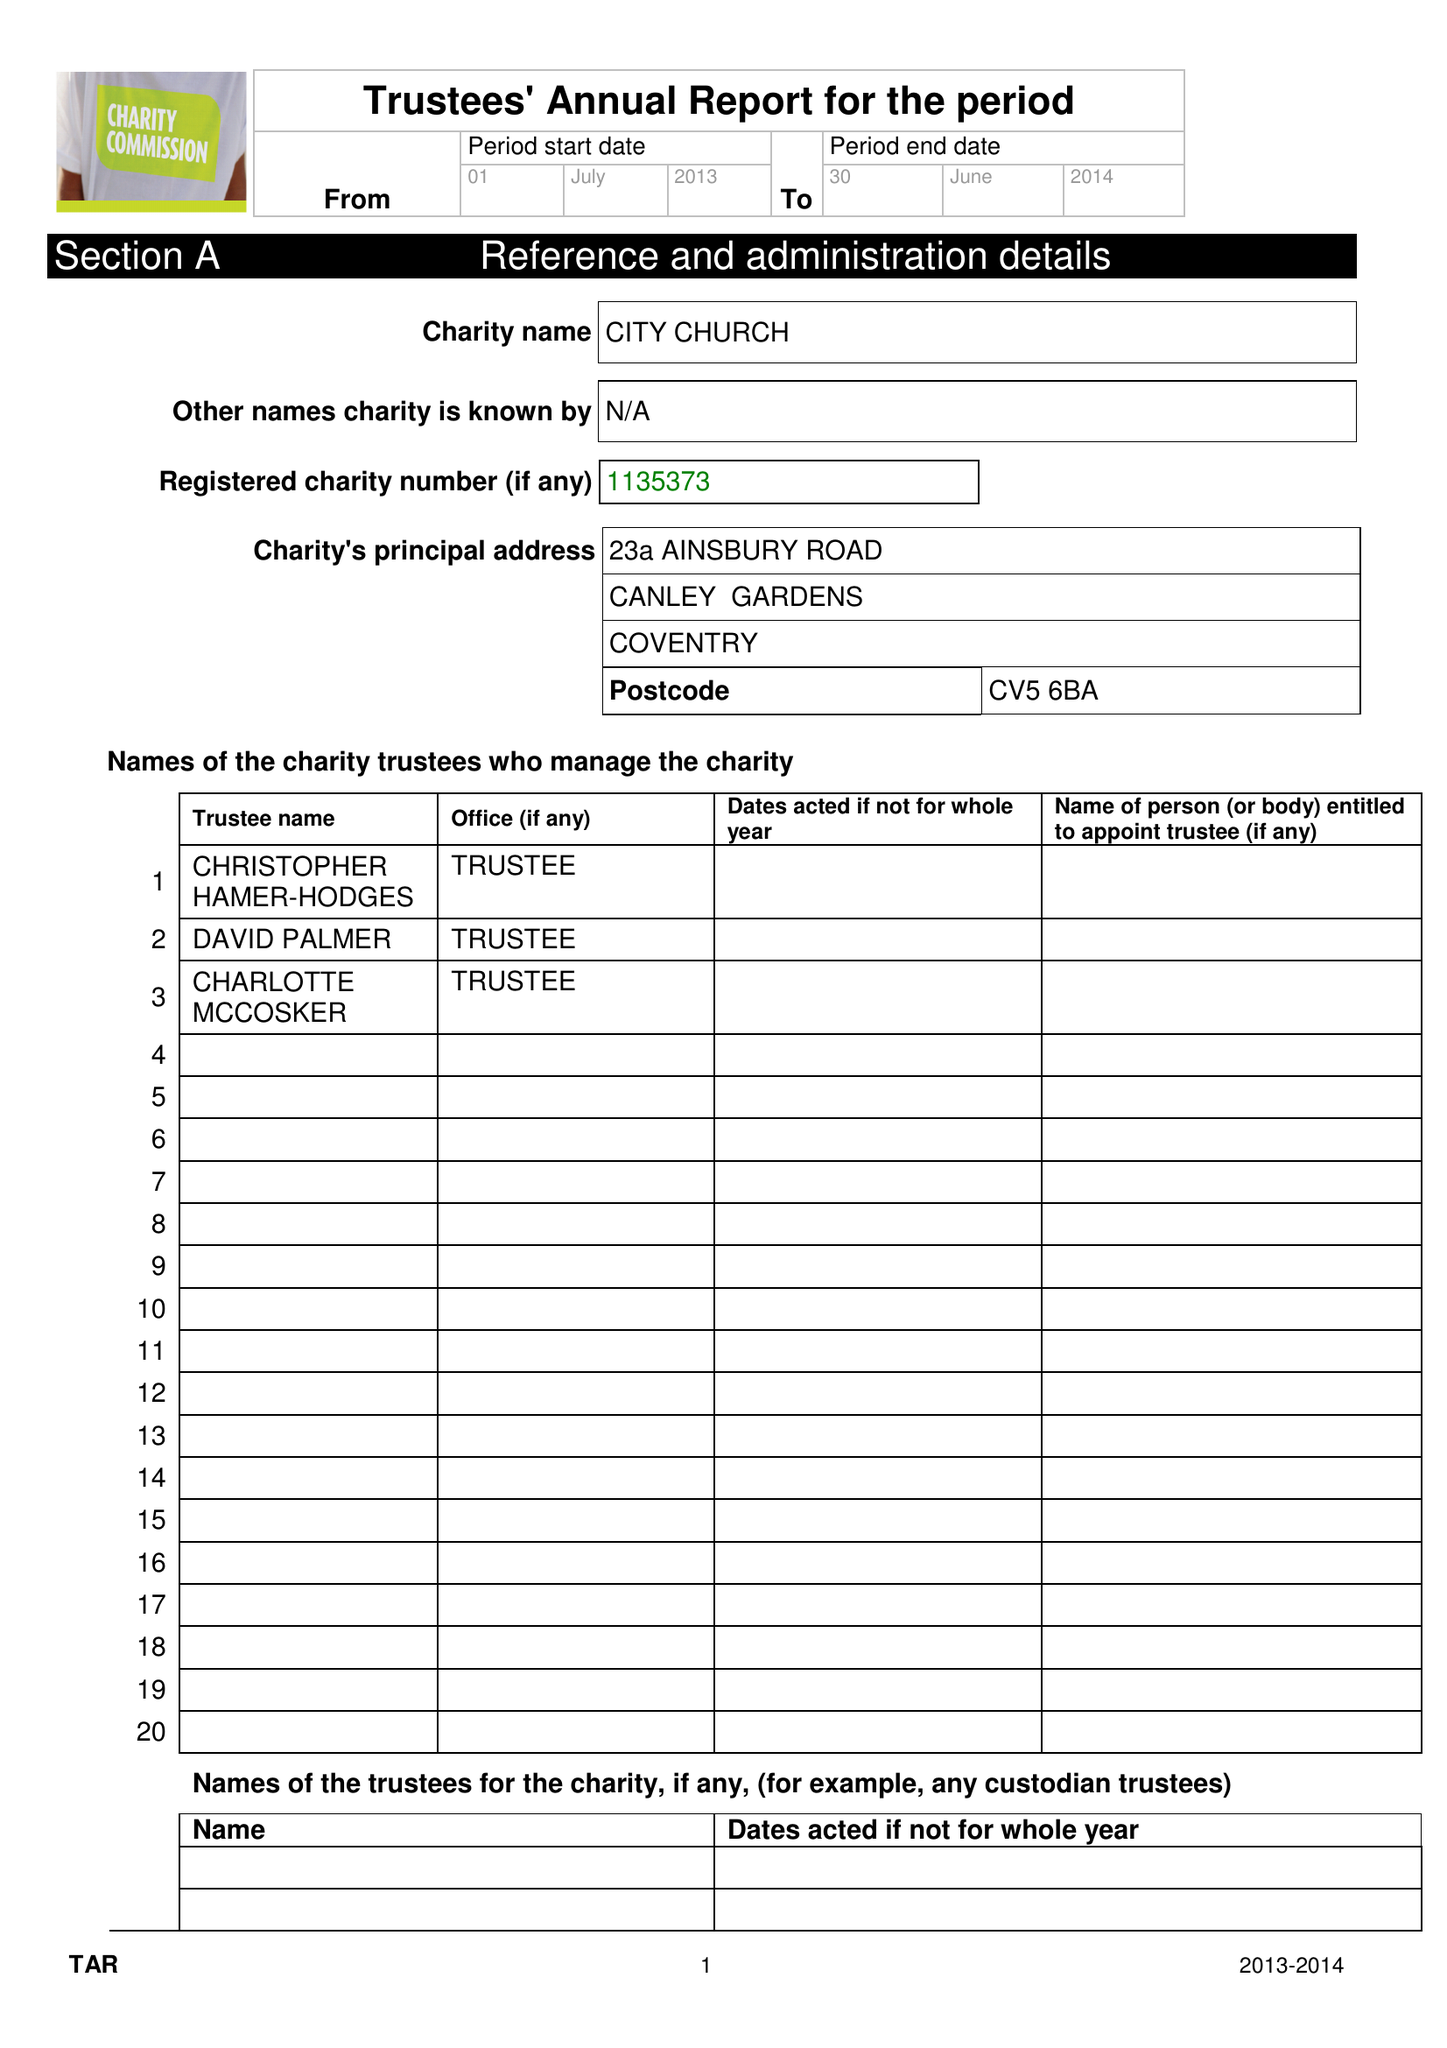What is the value for the address__post_town?
Answer the question using a single word or phrase. COVENTRY 